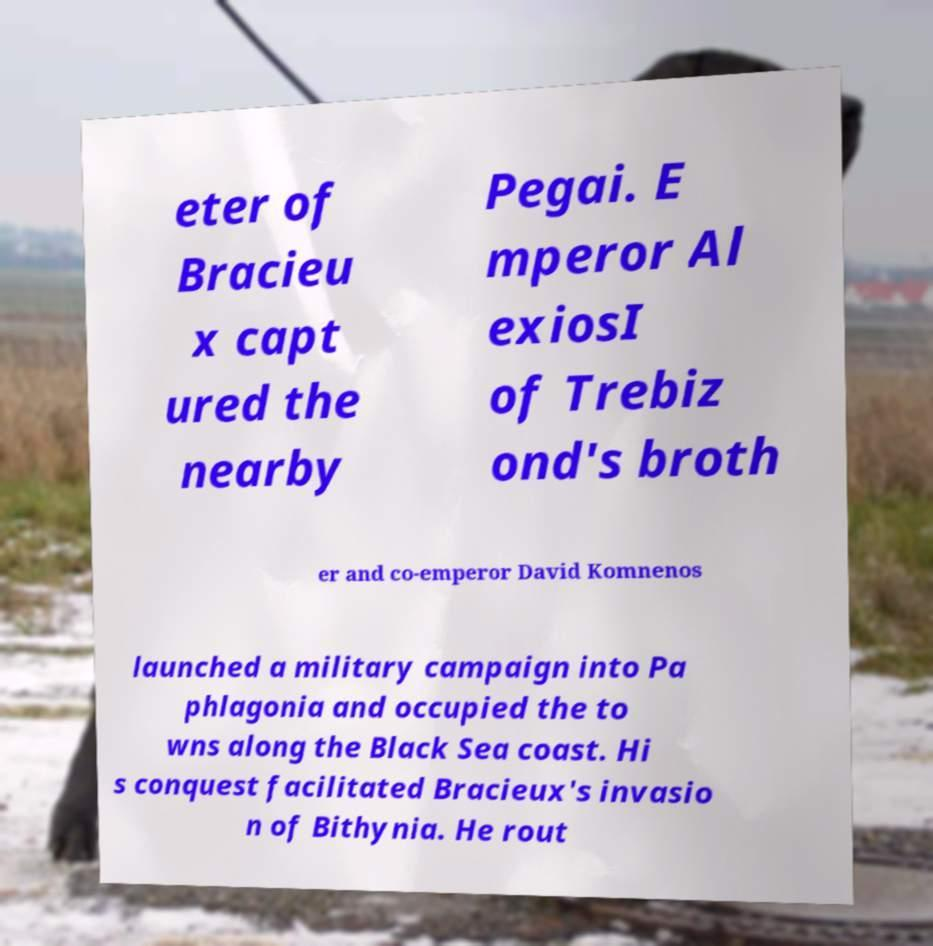I need the written content from this picture converted into text. Can you do that? eter of Bracieu x capt ured the nearby Pegai. E mperor Al exiosI of Trebiz ond's broth er and co-emperor David Komnenos launched a military campaign into Pa phlagonia and occupied the to wns along the Black Sea coast. Hi s conquest facilitated Bracieux's invasio n of Bithynia. He rout 